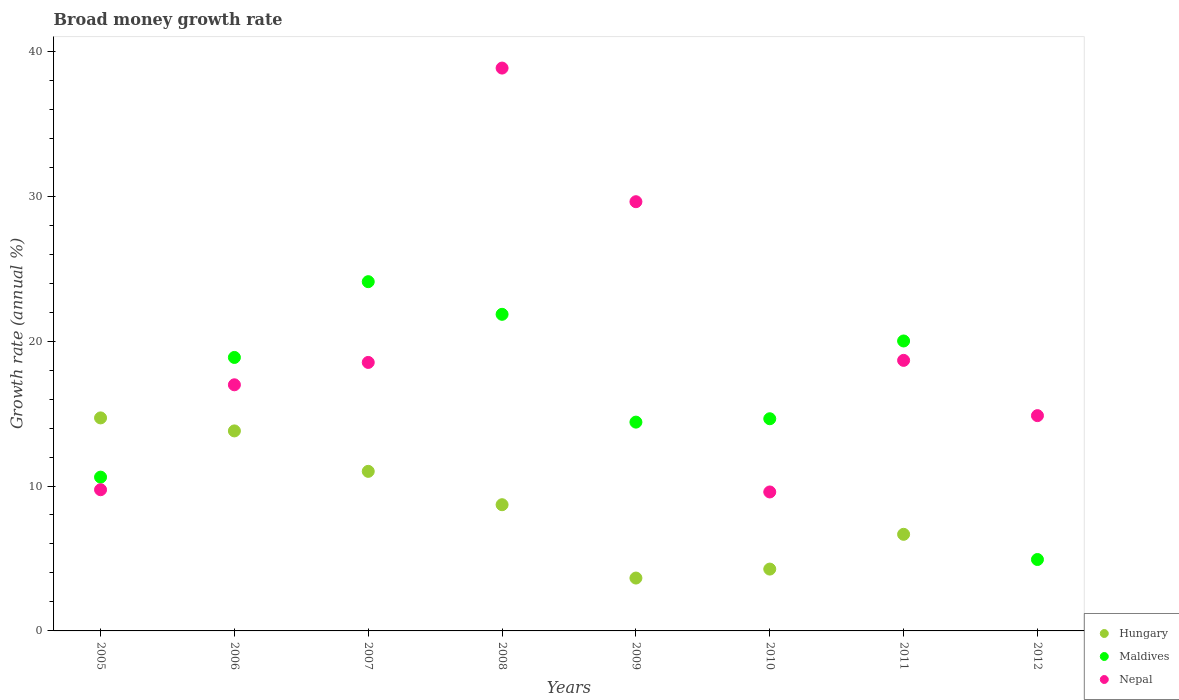Is the number of dotlines equal to the number of legend labels?
Offer a terse response. No. What is the growth rate in Nepal in 2010?
Provide a short and direct response. 9.59. Across all years, what is the maximum growth rate in Nepal?
Your response must be concise. 38.84. Across all years, what is the minimum growth rate in Nepal?
Your answer should be compact. 9.59. What is the total growth rate in Hungary in the graph?
Offer a very short reply. 62.81. What is the difference between the growth rate in Maldives in 2011 and that in 2012?
Your answer should be compact. 15.08. What is the difference between the growth rate in Hungary in 2005 and the growth rate in Nepal in 2009?
Ensure brevity in your answer.  -14.92. What is the average growth rate in Maldives per year?
Provide a succinct answer. 16.18. In the year 2006, what is the difference between the growth rate in Hungary and growth rate in Maldives?
Give a very brief answer. -5.07. What is the ratio of the growth rate in Hungary in 2006 to that in 2011?
Your response must be concise. 2.07. What is the difference between the highest and the second highest growth rate in Maldives?
Your answer should be compact. 2.25. What is the difference between the highest and the lowest growth rate in Hungary?
Your response must be concise. 14.7. Is it the case that in every year, the sum of the growth rate in Maldives and growth rate in Hungary  is greater than the growth rate in Nepal?
Your response must be concise. No. Is the growth rate in Nepal strictly less than the growth rate in Hungary over the years?
Keep it short and to the point. No. How many years are there in the graph?
Your answer should be very brief. 8. What is the difference between two consecutive major ticks on the Y-axis?
Give a very brief answer. 10. Does the graph contain any zero values?
Provide a short and direct response. Yes. Where does the legend appear in the graph?
Your answer should be compact. Bottom right. What is the title of the graph?
Provide a succinct answer. Broad money growth rate. What is the label or title of the Y-axis?
Ensure brevity in your answer.  Growth rate (annual %). What is the Growth rate (annual %) of Hungary in 2005?
Your answer should be compact. 14.7. What is the Growth rate (annual %) of Maldives in 2005?
Provide a short and direct response. 10.61. What is the Growth rate (annual %) of Nepal in 2005?
Your answer should be compact. 9.74. What is the Growth rate (annual %) in Hungary in 2006?
Provide a succinct answer. 13.8. What is the Growth rate (annual %) of Maldives in 2006?
Give a very brief answer. 18.87. What is the Growth rate (annual %) in Nepal in 2006?
Your response must be concise. 16.99. What is the Growth rate (annual %) of Hungary in 2007?
Provide a short and direct response. 11.01. What is the Growth rate (annual %) in Maldives in 2007?
Make the answer very short. 24.1. What is the Growth rate (annual %) in Nepal in 2007?
Provide a short and direct response. 18.53. What is the Growth rate (annual %) of Hungary in 2008?
Offer a very short reply. 8.71. What is the Growth rate (annual %) of Maldives in 2008?
Provide a short and direct response. 21.85. What is the Growth rate (annual %) of Nepal in 2008?
Ensure brevity in your answer.  38.84. What is the Growth rate (annual %) of Hungary in 2009?
Make the answer very short. 3.65. What is the Growth rate (annual %) in Maldives in 2009?
Ensure brevity in your answer.  14.41. What is the Growth rate (annual %) of Nepal in 2009?
Ensure brevity in your answer.  29.62. What is the Growth rate (annual %) in Hungary in 2010?
Your answer should be very brief. 4.27. What is the Growth rate (annual %) of Maldives in 2010?
Ensure brevity in your answer.  14.64. What is the Growth rate (annual %) of Nepal in 2010?
Offer a very short reply. 9.59. What is the Growth rate (annual %) of Hungary in 2011?
Provide a succinct answer. 6.67. What is the Growth rate (annual %) in Maldives in 2011?
Your answer should be compact. 20.01. What is the Growth rate (annual %) in Nepal in 2011?
Provide a short and direct response. 18.67. What is the Growth rate (annual %) in Maldives in 2012?
Keep it short and to the point. 4.93. What is the Growth rate (annual %) of Nepal in 2012?
Provide a short and direct response. 14.86. Across all years, what is the maximum Growth rate (annual %) of Hungary?
Keep it short and to the point. 14.7. Across all years, what is the maximum Growth rate (annual %) in Maldives?
Provide a succinct answer. 24.1. Across all years, what is the maximum Growth rate (annual %) in Nepal?
Make the answer very short. 38.84. Across all years, what is the minimum Growth rate (annual %) in Maldives?
Ensure brevity in your answer.  4.93. Across all years, what is the minimum Growth rate (annual %) of Nepal?
Keep it short and to the point. 9.59. What is the total Growth rate (annual %) in Hungary in the graph?
Provide a succinct answer. 62.81. What is the total Growth rate (annual %) of Maldives in the graph?
Your answer should be very brief. 129.42. What is the total Growth rate (annual %) of Nepal in the graph?
Provide a short and direct response. 156.83. What is the difference between the Growth rate (annual %) of Hungary in 2005 and that in 2006?
Make the answer very short. 0.9. What is the difference between the Growth rate (annual %) of Maldives in 2005 and that in 2006?
Your response must be concise. -8.26. What is the difference between the Growth rate (annual %) of Nepal in 2005 and that in 2006?
Your answer should be very brief. -7.24. What is the difference between the Growth rate (annual %) of Hungary in 2005 and that in 2007?
Your answer should be compact. 3.69. What is the difference between the Growth rate (annual %) of Maldives in 2005 and that in 2007?
Provide a short and direct response. -13.49. What is the difference between the Growth rate (annual %) in Nepal in 2005 and that in 2007?
Keep it short and to the point. -8.79. What is the difference between the Growth rate (annual %) in Hungary in 2005 and that in 2008?
Provide a short and direct response. 5.99. What is the difference between the Growth rate (annual %) of Maldives in 2005 and that in 2008?
Your response must be concise. -11.24. What is the difference between the Growth rate (annual %) of Nepal in 2005 and that in 2008?
Keep it short and to the point. -29.1. What is the difference between the Growth rate (annual %) in Hungary in 2005 and that in 2009?
Provide a short and direct response. 11.05. What is the difference between the Growth rate (annual %) of Maldives in 2005 and that in 2009?
Make the answer very short. -3.8. What is the difference between the Growth rate (annual %) of Nepal in 2005 and that in 2009?
Offer a terse response. -19.88. What is the difference between the Growth rate (annual %) in Hungary in 2005 and that in 2010?
Your answer should be compact. 10.43. What is the difference between the Growth rate (annual %) in Maldives in 2005 and that in 2010?
Make the answer very short. -4.03. What is the difference between the Growth rate (annual %) of Nepal in 2005 and that in 2010?
Make the answer very short. 0.15. What is the difference between the Growth rate (annual %) of Hungary in 2005 and that in 2011?
Keep it short and to the point. 8.03. What is the difference between the Growth rate (annual %) in Maldives in 2005 and that in 2011?
Your response must be concise. -9.4. What is the difference between the Growth rate (annual %) in Nepal in 2005 and that in 2011?
Give a very brief answer. -8.93. What is the difference between the Growth rate (annual %) in Maldives in 2005 and that in 2012?
Give a very brief answer. 5.68. What is the difference between the Growth rate (annual %) in Nepal in 2005 and that in 2012?
Ensure brevity in your answer.  -5.11. What is the difference between the Growth rate (annual %) in Hungary in 2006 and that in 2007?
Provide a short and direct response. 2.79. What is the difference between the Growth rate (annual %) in Maldives in 2006 and that in 2007?
Make the answer very short. -5.23. What is the difference between the Growth rate (annual %) in Nepal in 2006 and that in 2007?
Offer a terse response. -1.54. What is the difference between the Growth rate (annual %) of Hungary in 2006 and that in 2008?
Give a very brief answer. 5.09. What is the difference between the Growth rate (annual %) in Maldives in 2006 and that in 2008?
Your response must be concise. -2.98. What is the difference between the Growth rate (annual %) in Nepal in 2006 and that in 2008?
Your response must be concise. -21.86. What is the difference between the Growth rate (annual %) of Hungary in 2006 and that in 2009?
Make the answer very short. 10.15. What is the difference between the Growth rate (annual %) of Maldives in 2006 and that in 2009?
Provide a succinct answer. 4.46. What is the difference between the Growth rate (annual %) of Nepal in 2006 and that in 2009?
Keep it short and to the point. -12.63. What is the difference between the Growth rate (annual %) of Hungary in 2006 and that in 2010?
Keep it short and to the point. 9.54. What is the difference between the Growth rate (annual %) in Maldives in 2006 and that in 2010?
Your answer should be compact. 4.23. What is the difference between the Growth rate (annual %) of Nepal in 2006 and that in 2010?
Give a very brief answer. 7.4. What is the difference between the Growth rate (annual %) of Hungary in 2006 and that in 2011?
Offer a very short reply. 7.14. What is the difference between the Growth rate (annual %) in Maldives in 2006 and that in 2011?
Offer a terse response. -1.14. What is the difference between the Growth rate (annual %) of Nepal in 2006 and that in 2011?
Make the answer very short. -1.69. What is the difference between the Growth rate (annual %) of Maldives in 2006 and that in 2012?
Make the answer very short. 13.94. What is the difference between the Growth rate (annual %) in Nepal in 2006 and that in 2012?
Ensure brevity in your answer.  2.13. What is the difference between the Growth rate (annual %) in Hungary in 2007 and that in 2008?
Provide a short and direct response. 2.3. What is the difference between the Growth rate (annual %) of Maldives in 2007 and that in 2008?
Give a very brief answer. 2.25. What is the difference between the Growth rate (annual %) in Nepal in 2007 and that in 2008?
Your answer should be very brief. -20.31. What is the difference between the Growth rate (annual %) of Hungary in 2007 and that in 2009?
Keep it short and to the point. 7.36. What is the difference between the Growth rate (annual %) of Maldives in 2007 and that in 2009?
Give a very brief answer. 9.69. What is the difference between the Growth rate (annual %) in Nepal in 2007 and that in 2009?
Offer a terse response. -11.09. What is the difference between the Growth rate (annual %) of Hungary in 2007 and that in 2010?
Offer a very short reply. 6.74. What is the difference between the Growth rate (annual %) in Maldives in 2007 and that in 2010?
Provide a short and direct response. 9.46. What is the difference between the Growth rate (annual %) in Nepal in 2007 and that in 2010?
Give a very brief answer. 8.94. What is the difference between the Growth rate (annual %) of Hungary in 2007 and that in 2011?
Ensure brevity in your answer.  4.34. What is the difference between the Growth rate (annual %) in Maldives in 2007 and that in 2011?
Make the answer very short. 4.09. What is the difference between the Growth rate (annual %) of Nepal in 2007 and that in 2011?
Provide a short and direct response. -0.14. What is the difference between the Growth rate (annual %) in Maldives in 2007 and that in 2012?
Offer a terse response. 19.17. What is the difference between the Growth rate (annual %) in Nepal in 2007 and that in 2012?
Keep it short and to the point. 3.67. What is the difference between the Growth rate (annual %) of Hungary in 2008 and that in 2009?
Provide a succinct answer. 5.06. What is the difference between the Growth rate (annual %) in Maldives in 2008 and that in 2009?
Your answer should be very brief. 7.44. What is the difference between the Growth rate (annual %) of Nepal in 2008 and that in 2009?
Offer a terse response. 9.22. What is the difference between the Growth rate (annual %) of Hungary in 2008 and that in 2010?
Offer a terse response. 4.44. What is the difference between the Growth rate (annual %) of Maldives in 2008 and that in 2010?
Give a very brief answer. 7.21. What is the difference between the Growth rate (annual %) of Nepal in 2008 and that in 2010?
Keep it short and to the point. 29.25. What is the difference between the Growth rate (annual %) in Hungary in 2008 and that in 2011?
Provide a short and direct response. 2.04. What is the difference between the Growth rate (annual %) in Maldives in 2008 and that in 2011?
Give a very brief answer. 1.84. What is the difference between the Growth rate (annual %) of Nepal in 2008 and that in 2011?
Keep it short and to the point. 20.17. What is the difference between the Growth rate (annual %) of Maldives in 2008 and that in 2012?
Ensure brevity in your answer.  16.92. What is the difference between the Growth rate (annual %) in Nepal in 2008 and that in 2012?
Give a very brief answer. 23.98. What is the difference between the Growth rate (annual %) of Hungary in 2009 and that in 2010?
Offer a very short reply. -0.62. What is the difference between the Growth rate (annual %) in Maldives in 2009 and that in 2010?
Provide a short and direct response. -0.23. What is the difference between the Growth rate (annual %) in Nepal in 2009 and that in 2010?
Provide a short and direct response. 20.03. What is the difference between the Growth rate (annual %) of Hungary in 2009 and that in 2011?
Your answer should be very brief. -3.02. What is the difference between the Growth rate (annual %) in Nepal in 2009 and that in 2011?
Provide a succinct answer. 10.95. What is the difference between the Growth rate (annual %) of Maldives in 2009 and that in 2012?
Your answer should be compact. 9.48. What is the difference between the Growth rate (annual %) of Nepal in 2009 and that in 2012?
Ensure brevity in your answer.  14.76. What is the difference between the Growth rate (annual %) of Hungary in 2010 and that in 2011?
Keep it short and to the point. -2.4. What is the difference between the Growth rate (annual %) in Maldives in 2010 and that in 2011?
Your answer should be very brief. -5.37. What is the difference between the Growth rate (annual %) of Nepal in 2010 and that in 2011?
Offer a very short reply. -9.08. What is the difference between the Growth rate (annual %) of Maldives in 2010 and that in 2012?
Provide a short and direct response. 9.71. What is the difference between the Growth rate (annual %) in Nepal in 2010 and that in 2012?
Offer a very short reply. -5.27. What is the difference between the Growth rate (annual %) of Maldives in 2011 and that in 2012?
Ensure brevity in your answer.  15.08. What is the difference between the Growth rate (annual %) of Nepal in 2011 and that in 2012?
Your response must be concise. 3.81. What is the difference between the Growth rate (annual %) in Hungary in 2005 and the Growth rate (annual %) in Maldives in 2006?
Offer a very short reply. -4.17. What is the difference between the Growth rate (annual %) in Hungary in 2005 and the Growth rate (annual %) in Nepal in 2006?
Make the answer very short. -2.28. What is the difference between the Growth rate (annual %) of Maldives in 2005 and the Growth rate (annual %) of Nepal in 2006?
Provide a succinct answer. -6.37. What is the difference between the Growth rate (annual %) in Hungary in 2005 and the Growth rate (annual %) in Maldives in 2007?
Offer a very short reply. -9.4. What is the difference between the Growth rate (annual %) in Hungary in 2005 and the Growth rate (annual %) in Nepal in 2007?
Provide a succinct answer. -3.83. What is the difference between the Growth rate (annual %) of Maldives in 2005 and the Growth rate (annual %) of Nepal in 2007?
Offer a very short reply. -7.92. What is the difference between the Growth rate (annual %) in Hungary in 2005 and the Growth rate (annual %) in Maldives in 2008?
Make the answer very short. -7.15. What is the difference between the Growth rate (annual %) in Hungary in 2005 and the Growth rate (annual %) in Nepal in 2008?
Make the answer very short. -24.14. What is the difference between the Growth rate (annual %) of Maldives in 2005 and the Growth rate (annual %) of Nepal in 2008?
Give a very brief answer. -28.23. What is the difference between the Growth rate (annual %) in Hungary in 2005 and the Growth rate (annual %) in Maldives in 2009?
Offer a terse response. 0.29. What is the difference between the Growth rate (annual %) of Hungary in 2005 and the Growth rate (annual %) of Nepal in 2009?
Provide a short and direct response. -14.92. What is the difference between the Growth rate (annual %) of Maldives in 2005 and the Growth rate (annual %) of Nepal in 2009?
Ensure brevity in your answer.  -19.01. What is the difference between the Growth rate (annual %) in Hungary in 2005 and the Growth rate (annual %) in Maldives in 2010?
Your response must be concise. 0.06. What is the difference between the Growth rate (annual %) in Hungary in 2005 and the Growth rate (annual %) in Nepal in 2010?
Make the answer very short. 5.11. What is the difference between the Growth rate (annual %) of Maldives in 2005 and the Growth rate (annual %) of Nepal in 2010?
Ensure brevity in your answer.  1.02. What is the difference between the Growth rate (annual %) of Hungary in 2005 and the Growth rate (annual %) of Maldives in 2011?
Provide a short and direct response. -5.31. What is the difference between the Growth rate (annual %) in Hungary in 2005 and the Growth rate (annual %) in Nepal in 2011?
Keep it short and to the point. -3.97. What is the difference between the Growth rate (annual %) of Maldives in 2005 and the Growth rate (annual %) of Nepal in 2011?
Provide a succinct answer. -8.06. What is the difference between the Growth rate (annual %) in Hungary in 2005 and the Growth rate (annual %) in Maldives in 2012?
Offer a terse response. 9.77. What is the difference between the Growth rate (annual %) in Hungary in 2005 and the Growth rate (annual %) in Nepal in 2012?
Offer a terse response. -0.16. What is the difference between the Growth rate (annual %) in Maldives in 2005 and the Growth rate (annual %) in Nepal in 2012?
Give a very brief answer. -4.24. What is the difference between the Growth rate (annual %) in Hungary in 2006 and the Growth rate (annual %) in Maldives in 2007?
Ensure brevity in your answer.  -10.3. What is the difference between the Growth rate (annual %) in Hungary in 2006 and the Growth rate (annual %) in Nepal in 2007?
Make the answer very short. -4.73. What is the difference between the Growth rate (annual %) of Maldives in 2006 and the Growth rate (annual %) of Nepal in 2007?
Provide a short and direct response. 0.34. What is the difference between the Growth rate (annual %) of Hungary in 2006 and the Growth rate (annual %) of Maldives in 2008?
Ensure brevity in your answer.  -8.05. What is the difference between the Growth rate (annual %) in Hungary in 2006 and the Growth rate (annual %) in Nepal in 2008?
Ensure brevity in your answer.  -25.04. What is the difference between the Growth rate (annual %) in Maldives in 2006 and the Growth rate (annual %) in Nepal in 2008?
Provide a short and direct response. -19.97. What is the difference between the Growth rate (annual %) in Hungary in 2006 and the Growth rate (annual %) in Maldives in 2009?
Your response must be concise. -0.61. What is the difference between the Growth rate (annual %) in Hungary in 2006 and the Growth rate (annual %) in Nepal in 2009?
Provide a succinct answer. -15.82. What is the difference between the Growth rate (annual %) in Maldives in 2006 and the Growth rate (annual %) in Nepal in 2009?
Give a very brief answer. -10.75. What is the difference between the Growth rate (annual %) in Hungary in 2006 and the Growth rate (annual %) in Maldives in 2010?
Offer a terse response. -0.84. What is the difference between the Growth rate (annual %) of Hungary in 2006 and the Growth rate (annual %) of Nepal in 2010?
Your answer should be compact. 4.21. What is the difference between the Growth rate (annual %) in Maldives in 2006 and the Growth rate (annual %) in Nepal in 2010?
Ensure brevity in your answer.  9.28. What is the difference between the Growth rate (annual %) in Hungary in 2006 and the Growth rate (annual %) in Maldives in 2011?
Your answer should be very brief. -6.21. What is the difference between the Growth rate (annual %) of Hungary in 2006 and the Growth rate (annual %) of Nepal in 2011?
Your answer should be very brief. -4.87. What is the difference between the Growth rate (annual %) in Maldives in 2006 and the Growth rate (annual %) in Nepal in 2011?
Offer a terse response. 0.2. What is the difference between the Growth rate (annual %) in Hungary in 2006 and the Growth rate (annual %) in Maldives in 2012?
Keep it short and to the point. 8.87. What is the difference between the Growth rate (annual %) of Hungary in 2006 and the Growth rate (annual %) of Nepal in 2012?
Your response must be concise. -1.05. What is the difference between the Growth rate (annual %) of Maldives in 2006 and the Growth rate (annual %) of Nepal in 2012?
Keep it short and to the point. 4.02. What is the difference between the Growth rate (annual %) in Hungary in 2007 and the Growth rate (annual %) in Maldives in 2008?
Offer a terse response. -10.84. What is the difference between the Growth rate (annual %) of Hungary in 2007 and the Growth rate (annual %) of Nepal in 2008?
Offer a terse response. -27.83. What is the difference between the Growth rate (annual %) of Maldives in 2007 and the Growth rate (annual %) of Nepal in 2008?
Provide a succinct answer. -14.74. What is the difference between the Growth rate (annual %) of Hungary in 2007 and the Growth rate (annual %) of Maldives in 2009?
Provide a short and direct response. -3.4. What is the difference between the Growth rate (annual %) of Hungary in 2007 and the Growth rate (annual %) of Nepal in 2009?
Give a very brief answer. -18.61. What is the difference between the Growth rate (annual %) in Maldives in 2007 and the Growth rate (annual %) in Nepal in 2009?
Your response must be concise. -5.52. What is the difference between the Growth rate (annual %) of Hungary in 2007 and the Growth rate (annual %) of Maldives in 2010?
Your response must be concise. -3.63. What is the difference between the Growth rate (annual %) in Hungary in 2007 and the Growth rate (annual %) in Nepal in 2010?
Offer a very short reply. 1.42. What is the difference between the Growth rate (annual %) in Maldives in 2007 and the Growth rate (annual %) in Nepal in 2010?
Provide a short and direct response. 14.51. What is the difference between the Growth rate (annual %) in Hungary in 2007 and the Growth rate (annual %) in Maldives in 2011?
Ensure brevity in your answer.  -9. What is the difference between the Growth rate (annual %) of Hungary in 2007 and the Growth rate (annual %) of Nepal in 2011?
Offer a terse response. -7.66. What is the difference between the Growth rate (annual %) of Maldives in 2007 and the Growth rate (annual %) of Nepal in 2011?
Provide a short and direct response. 5.43. What is the difference between the Growth rate (annual %) in Hungary in 2007 and the Growth rate (annual %) in Maldives in 2012?
Give a very brief answer. 6.08. What is the difference between the Growth rate (annual %) of Hungary in 2007 and the Growth rate (annual %) of Nepal in 2012?
Ensure brevity in your answer.  -3.84. What is the difference between the Growth rate (annual %) of Maldives in 2007 and the Growth rate (annual %) of Nepal in 2012?
Give a very brief answer. 9.24. What is the difference between the Growth rate (annual %) of Hungary in 2008 and the Growth rate (annual %) of Maldives in 2009?
Offer a very short reply. -5.7. What is the difference between the Growth rate (annual %) in Hungary in 2008 and the Growth rate (annual %) in Nepal in 2009?
Make the answer very short. -20.91. What is the difference between the Growth rate (annual %) of Maldives in 2008 and the Growth rate (annual %) of Nepal in 2009?
Provide a short and direct response. -7.77. What is the difference between the Growth rate (annual %) of Hungary in 2008 and the Growth rate (annual %) of Maldives in 2010?
Offer a very short reply. -5.93. What is the difference between the Growth rate (annual %) in Hungary in 2008 and the Growth rate (annual %) in Nepal in 2010?
Keep it short and to the point. -0.88. What is the difference between the Growth rate (annual %) in Maldives in 2008 and the Growth rate (annual %) in Nepal in 2010?
Keep it short and to the point. 12.26. What is the difference between the Growth rate (annual %) of Hungary in 2008 and the Growth rate (annual %) of Maldives in 2011?
Offer a very short reply. -11.3. What is the difference between the Growth rate (annual %) of Hungary in 2008 and the Growth rate (annual %) of Nepal in 2011?
Your response must be concise. -9.96. What is the difference between the Growth rate (annual %) in Maldives in 2008 and the Growth rate (annual %) in Nepal in 2011?
Offer a very short reply. 3.18. What is the difference between the Growth rate (annual %) in Hungary in 2008 and the Growth rate (annual %) in Maldives in 2012?
Keep it short and to the point. 3.78. What is the difference between the Growth rate (annual %) in Hungary in 2008 and the Growth rate (annual %) in Nepal in 2012?
Your answer should be very brief. -6.15. What is the difference between the Growth rate (annual %) in Maldives in 2008 and the Growth rate (annual %) in Nepal in 2012?
Offer a very short reply. 6.99. What is the difference between the Growth rate (annual %) in Hungary in 2009 and the Growth rate (annual %) in Maldives in 2010?
Ensure brevity in your answer.  -10.99. What is the difference between the Growth rate (annual %) in Hungary in 2009 and the Growth rate (annual %) in Nepal in 2010?
Provide a short and direct response. -5.94. What is the difference between the Growth rate (annual %) in Maldives in 2009 and the Growth rate (annual %) in Nepal in 2010?
Give a very brief answer. 4.82. What is the difference between the Growth rate (annual %) in Hungary in 2009 and the Growth rate (annual %) in Maldives in 2011?
Keep it short and to the point. -16.36. What is the difference between the Growth rate (annual %) of Hungary in 2009 and the Growth rate (annual %) of Nepal in 2011?
Your answer should be very brief. -15.02. What is the difference between the Growth rate (annual %) in Maldives in 2009 and the Growth rate (annual %) in Nepal in 2011?
Your response must be concise. -4.26. What is the difference between the Growth rate (annual %) of Hungary in 2009 and the Growth rate (annual %) of Maldives in 2012?
Offer a very short reply. -1.28. What is the difference between the Growth rate (annual %) in Hungary in 2009 and the Growth rate (annual %) in Nepal in 2012?
Your answer should be very brief. -11.21. What is the difference between the Growth rate (annual %) in Maldives in 2009 and the Growth rate (annual %) in Nepal in 2012?
Keep it short and to the point. -0.45. What is the difference between the Growth rate (annual %) of Hungary in 2010 and the Growth rate (annual %) of Maldives in 2011?
Provide a short and direct response. -15.74. What is the difference between the Growth rate (annual %) of Hungary in 2010 and the Growth rate (annual %) of Nepal in 2011?
Provide a succinct answer. -14.4. What is the difference between the Growth rate (annual %) of Maldives in 2010 and the Growth rate (annual %) of Nepal in 2011?
Provide a succinct answer. -4.03. What is the difference between the Growth rate (annual %) of Hungary in 2010 and the Growth rate (annual %) of Maldives in 2012?
Your answer should be compact. -0.66. What is the difference between the Growth rate (annual %) of Hungary in 2010 and the Growth rate (annual %) of Nepal in 2012?
Provide a short and direct response. -10.59. What is the difference between the Growth rate (annual %) of Maldives in 2010 and the Growth rate (annual %) of Nepal in 2012?
Offer a terse response. -0.21. What is the difference between the Growth rate (annual %) of Hungary in 2011 and the Growth rate (annual %) of Maldives in 2012?
Ensure brevity in your answer.  1.74. What is the difference between the Growth rate (annual %) of Hungary in 2011 and the Growth rate (annual %) of Nepal in 2012?
Your response must be concise. -8.19. What is the difference between the Growth rate (annual %) of Maldives in 2011 and the Growth rate (annual %) of Nepal in 2012?
Provide a succinct answer. 5.15. What is the average Growth rate (annual %) in Hungary per year?
Keep it short and to the point. 7.85. What is the average Growth rate (annual %) of Maldives per year?
Your answer should be compact. 16.18. What is the average Growth rate (annual %) of Nepal per year?
Ensure brevity in your answer.  19.6. In the year 2005, what is the difference between the Growth rate (annual %) in Hungary and Growth rate (annual %) in Maldives?
Ensure brevity in your answer.  4.09. In the year 2005, what is the difference between the Growth rate (annual %) in Hungary and Growth rate (annual %) in Nepal?
Ensure brevity in your answer.  4.96. In the year 2005, what is the difference between the Growth rate (annual %) in Maldives and Growth rate (annual %) in Nepal?
Provide a short and direct response. 0.87. In the year 2006, what is the difference between the Growth rate (annual %) of Hungary and Growth rate (annual %) of Maldives?
Offer a terse response. -5.07. In the year 2006, what is the difference between the Growth rate (annual %) in Hungary and Growth rate (annual %) in Nepal?
Make the answer very short. -3.18. In the year 2006, what is the difference between the Growth rate (annual %) of Maldives and Growth rate (annual %) of Nepal?
Offer a terse response. 1.89. In the year 2007, what is the difference between the Growth rate (annual %) in Hungary and Growth rate (annual %) in Maldives?
Keep it short and to the point. -13.09. In the year 2007, what is the difference between the Growth rate (annual %) in Hungary and Growth rate (annual %) in Nepal?
Make the answer very short. -7.52. In the year 2007, what is the difference between the Growth rate (annual %) of Maldives and Growth rate (annual %) of Nepal?
Provide a succinct answer. 5.57. In the year 2008, what is the difference between the Growth rate (annual %) in Hungary and Growth rate (annual %) in Maldives?
Offer a very short reply. -13.14. In the year 2008, what is the difference between the Growth rate (annual %) of Hungary and Growth rate (annual %) of Nepal?
Keep it short and to the point. -30.13. In the year 2008, what is the difference between the Growth rate (annual %) of Maldives and Growth rate (annual %) of Nepal?
Offer a terse response. -16.99. In the year 2009, what is the difference between the Growth rate (annual %) in Hungary and Growth rate (annual %) in Maldives?
Make the answer very short. -10.76. In the year 2009, what is the difference between the Growth rate (annual %) of Hungary and Growth rate (annual %) of Nepal?
Your answer should be compact. -25.97. In the year 2009, what is the difference between the Growth rate (annual %) in Maldives and Growth rate (annual %) in Nepal?
Your answer should be very brief. -15.21. In the year 2010, what is the difference between the Growth rate (annual %) of Hungary and Growth rate (annual %) of Maldives?
Your answer should be compact. -10.37. In the year 2010, what is the difference between the Growth rate (annual %) of Hungary and Growth rate (annual %) of Nepal?
Provide a succinct answer. -5.32. In the year 2010, what is the difference between the Growth rate (annual %) of Maldives and Growth rate (annual %) of Nepal?
Offer a very short reply. 5.05. In the year 2011, what is the difference between the Growth rate (annual %) in Hungary and Growth rate (annual %) in Maldives?
Your answer should be very brief. -13.34. In the year 2011, what is the difference between the Growth rate (annual %) of Hungary and Growth rate (annual %) of Nepal?
Offer a terse response. -12. In the year 2011, what is the difference between the Growth rate (annual %) in Maldives and Growth rate (annual %) in Nepal?
Make the answer very short. 1.34. In the year 2012, what is the difference between the Growth rate (annual %) in Maldives and Growth rate (annual %) in Nepal?
Provide a succinct answer. -9.93. What is the ratio of the Growth rate (annual %) of Hungary in 2005 to that in 2006?
Ensure brevity in your answer.  1.06. What is the ratio of the Growth rate (annual %) of Maldives in 2005 to that in 2006?
Provide a short and direct response. 0.56. What is the ratio of the Growth rate (annual %) of Nepal in 2005 to that in 2006?
Your response must be concise. 0.57. What is the ratio of the Growth rate (annual %) of Hungary in 2005 to that in 2007?
Your answer should be compact. 1.33. What is the ratio of the Growth rate (annual %) of Maldives in 2005 to that in 2007?
Offer a terse response. 0.44. What is the ratio of the Growth rate (annual %) in Nepal in 2005 to that in 2007?
Give a very brief answer. 0.53. What is the ratio of the Growth rate (annual %) of Hungary in 2005 to that in 2008?
Your response must be concise. 1.69. What is the ratio of the Growth rate (annual %) in Maldives in 2005 to that in 2008?
Offer a terse response. 0.49. What is the ratio of the Growth rate (annual %) in Nepal in 2005 to that in 2008?
Your answer should be very brief. 0.25. What is the ratio of the Growth rate (annual %) in Hungary in 2005 to that in 2009?
Provide a succinct answer. 4.03. What is the ratio of the Growth rate (annual %) in Maldives in 2005 to that in 2009?
Ensure brevity in your answer.  0.74. What is the ratio of the Growth rate (annual %) in Nepal in 2005 to that in 2009?
Provide a short and direct response. 0.33. What is the ratio of the Growth rate (annual %) in Hungary in 2005 to that in 2010?
Your response must be concise. 3.44. What is the ratio of the Growth rate (annual %) of Maldives in 2005 to that in 2010?
Give a very brief answer. 0.72. What is the ratio of the Growth rate (annual %) in Nepal in 2005 to that in 2010?
Your answer should be very brief. 1.02. What is the ratio of the Growth rate (annual %) in Hungary in 2005 to that in 2011?
Give a very brief answer. 2.21. What is the ratio of the Growth rate (annual %) of Maldives in 2005 to that in 2011?
Offer a very short reply. 0.53. What is the ratio of the Growth rate (annual %) in Nepal in 2005 to that in 2011?
Give a very brief answer. 0.52. What is the ratio of the Growth rate (annual %) of Maldives in 2005 to that in 2012?
Offer a terse response. 2.15. What is the ratio of the Growth rate (annual %) of Nepal in 2005 to that in 2012?
Your response must be concise. 0.66. What is the ratio of the Growth rate (annual %) of Hungary in 2006 to that in 2007?
Your response must be concise. 1.25. What is the ratio of the Growth rate (annual %) of Maldives in 2006 to that in 2007?
Give a very brief answer. 0.78. What is the ratio of the Growth rate (annual %) of Nepal in 2006 to that in 2007?
Your answer should be compact. 0.92. What is the ratio of the Growth rate (annual %) in Hungary in 2006 to that in 2008?
Provide a short and direct response. 1.58. What is the ratio of the Growth rate (annual %) of Maldives in 2006 to that in 2008?
Ensure brevity in your answer.  0.86. What is the ratio of the Growth rate (annual %) in Nepal in 2006 to that in 2008?
Give a very brief answer. 0.44. What is the ratio of the Growth rate (annual %) in Hungary in 2006 to that in 2009?
Your response must be concise. 3.78. What is the ratio of the Growth rate (annual %) in Maldives in 2006 to that in 2009?
Your answer should be very brief. 1.31. What is the ratio of the Growth rate (annual %) of Nepal in 2006 to that in 2009?
Your response must be concise. 0.57. What is the ratio of the Growth rate (annual %) of Hungary in 2006 to that in 2010?
Make the answer very short. 3.23. What is the ratio of the Growth rate (annual %) in Maldives in 2006 to that in 2010?
Your answer should be compact. 1.29. What is the ratio of the Growth rate (annual %) of Nepal in 2006 to that in 2010?
Your answer should be compact. 1.77. What is the ratio of the Growth rate (annual %) in Hungary in 2006 to that in 2011?
Your answer should be compact. 2.07. What is the ratio of the Growth rate (annual %) in Maldives in 2006 to that in 2011?
Give a very brief answer. 0.94. What is the ratio of the Growth rate (annual %) of Nepal in 2006 to that in 2011?
Make the answer very short. 0.91. What is the ratio of the Growth rate (annual %) in Maldives in 2006 to that in 2012?
Keep it short and to the point. 3.83. What is the ratio of the Growth rate (annual %) in Nepal in 2006 to that in 2012?
Your response must be concise. 1.14. What is the ratio of the Growth rate (annual %) in Hungary in 2007 to that in 2008?
Offer a very short reply. 1.26. What is the ratio of the Growth rate (annual %) in Maldives in 2007 to that in 2008?
Your response must be concise. 1.1. What is the ratio of the Growth rate (annual %) in Nepal in 2007 to that in 2008?
Your answer should be very brief. 0.48. What is the ratio of the Growth rate (annual %) in Hungary in 2007 to that in 2009?
Your response must be concise. 3.02. What is the ratio of the Growth rate (annual %) of Maldives in 2007 to that in 2009?
Provide a succinct answer. 1.67. What is the ratio of the Growth rate (annual %) in Nepal in 2007 to that in 2009?
Your answer should be compact. 0.63. What is the ratio of the Growth rate (annual %) of Hungary in 2007 to that in 2010?
Make the answer very short. 2.58. What is the ratio of the Growth rate (annual %) in Maldives in 2007 to that in 2010?
Provide a short and direct response. 1.65. What is the ratio of the Growth rate (annual %) of Nepal in 2007 to that in 2010?
Offer a terse response. 1.93. What is the ratio of the Growth rate (annual %) of Hungary in 2007 to that in 2011?
Make the answer very short. 1.65. What is the ratio of the Growth rate (annual %) of Maldives in 2007 to that in 2011?
Make the answer very short. 1.2. What is the ratio of the Growth rate (annual %) of Nepal in 2007 to that in 2011?
Make the answer very short. 0.99. What is the ratio of the Growth rate (annual %) of Maldives in 2007 to that in 2012?
Your response must be concise. 4.89. What is the ratio of the Growth rate (annual %) in Nepal in 2007 to that in 2012?
Your answer should be very brief. 1.25. What is the ratio of the Growth rate (annual %) of Hungary in 2008 to that in 2009?
Provide a short and direct response. 2.39. What is the ratio of the Growth rate (annual %) in Maldives in 2008 to that in 2009?
Provide a succinct answer. 1.52. What is the ratio of the Growth rate (annual %) of Nepal in 2008 to that in 2009?
Your response must be concise. 1.31. What is the ratio of the Growth rate (annual %) in Hungary in 2008 to that in 2010?
Ensure brevity in your answer.  2.04. What is the ratio of the Growth rate (annual %) in Maldives in 2008 to that in 2010?
Offer a terse response. 1.49. What is the ratio of the Growth rate (annual %) of Nepal in 2008 to that in 2010?
Make the answer very short. 4.05. What is the ratio of the Growth rate (annual %) of Hungary in 2008 to that in 2011?
Provide a short and direct response. 1.31. What is the ratio of the Growth rate (annual %) of Maldives in 2008 to that in 2011?
Give a very brief answer. 1.09. What is the ratio of the Growth rate (annual %) in Nepal in 2008 to that in 2011?
Provide a short and direct response. 2.08. What is the ratio of the Growth rate (annual %) in Maldives in 2008 to that in 2012?
Offer a very short reply. 4.43. What is the ratio of the Growth rate (annual %) in Nepal in 2008 to that in 2012?
Your answer should be very brief. 2.61. What is the ratio of the Growth rate (annual %) in Hungary in 2009 to that in 2010?
Your response must be concise. 0.85. What is the ratio of the Growth rate (annual %) in Maldives in 2009 to that in 2010?
Offer a terse response. 0.98. What is the ratio of the Growth rate (annual %) of Nepal in 2009 to that in 2010?
Offer a terse response. 3.09. What is the ratio of the Growth rate (annual %) in Hungary in 2009 to that in 2011?
Offer a very short reply. 0.55. What is the ratio of the Growth rate (annual %) of Maldives in 2009 to that in 2011?
Ensure brevity in your answer.  0.72. What is the ratio of the Growth rate (annual %) of Nepal in 2009 to that in 2011?
Your response must be concise. 1.59. What is the ratio of the Growth rate (annual %) of Maldives in 2009 to that in 2012?
Provide a succinct answer. 2.92. What is the ratio of the Growth rate (annual %) of Nepal in 2009 to that in 2012?
Ensure brevity in your answer.  1.99. What is the ratio of the Growth rate (annual %) in Hungary in 2010 to that in 2011?
Keep it short and to the point. 0.64. What is the ratio of the Growth rate (annual %) of Maldives in 2010 to that in 2011?
Your answer should be very brief. 0.73. What is the ratio of the Growth rate (annual %) of Nepal in 2010 to that in 2011?
Offer a terse response. 0.51. What is the ratio of the Growth rate (annual %) in Maldives in 2010 to that in 2012?
Your answer should be compact. 2.97. What is the ratio of the Growth rate (annual %) of Nepal in 2010 to that in 2012?
Ensure brevity in your answer.  0.65. What is the ratio of the Growth rate (annual %) in Maldives in 2011 to that in 2012?
Give a very brief answer. 4.06. What is the ratio of the Growth rate (annual %) in Nepal in 2011 to that in 2012?
Provide a succinct answer. 1.26. What is the difference between the highest and the second highest Growth rate (annual %) of Hungary?
Provide a succinct answer. 0.9. What is the difference between the highest and the second highest Growth rate (annual %) of Maldives?
Provide a short and direct response. 2.25. What is the difference between the highest and the second highest Growth rate (annual %) of Nepal?
Offer a terse response. 9.22. What is the difference between the highest and the lowest Growth rate (annual %) in Hungary?
Ensure brevity in your answer.  14.7. What is the difference between the highest and the lowest Growth rate (annual %) of Maldives?
Ensure brevity in your answer.  19.17. What is the difference between the highest and the lowest Growth rate (annual %) of Nepal?
Provide a short and direct response. 29.25. 